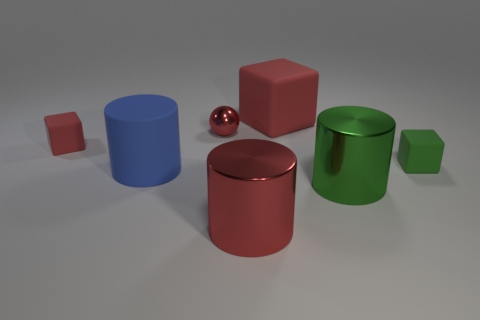Subtract all large rubber cubes. How many cubes are left? 2 Subtract all green spheres. How many red blocks are left? 2 Add 1 large red metal cylinders. How many objects exist? 8 Subtract all cyan cylinders. Subtract all green spheres. How many cylinders are left? 3 Subtract all blocks. How many objects are left? 4 Subtract all brown metal spheres. Subtract all small green matte objects. How many objects are left? 6 Add 7 big blue matte things. How many big blue matte things are left? 8 Add 4 large red objects. How many large red objects exist? 6 Subtract 0 cyan cubes. How many objects are left? 7 